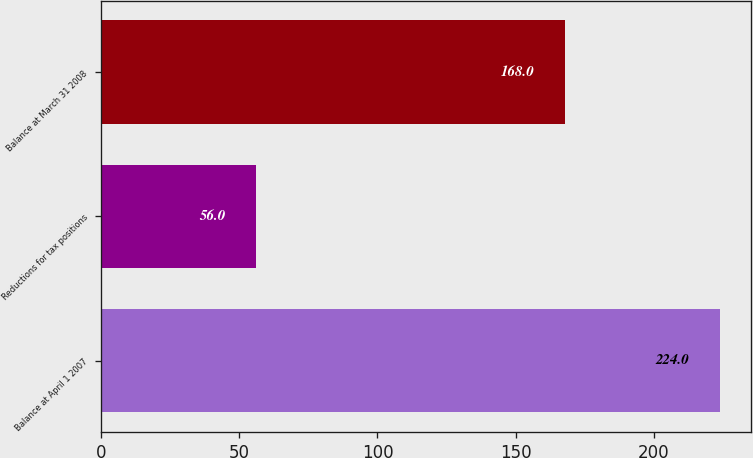<chart> <loc_0><loc_0><loc_500><loc_500><bar_chart><fcel>Balance at April 1 2007<fcel>Reductions for tax positions<fcel>Balance at March 31 2008<nl><fcel>224<fcel>56<fcel>168<nl></chart> 